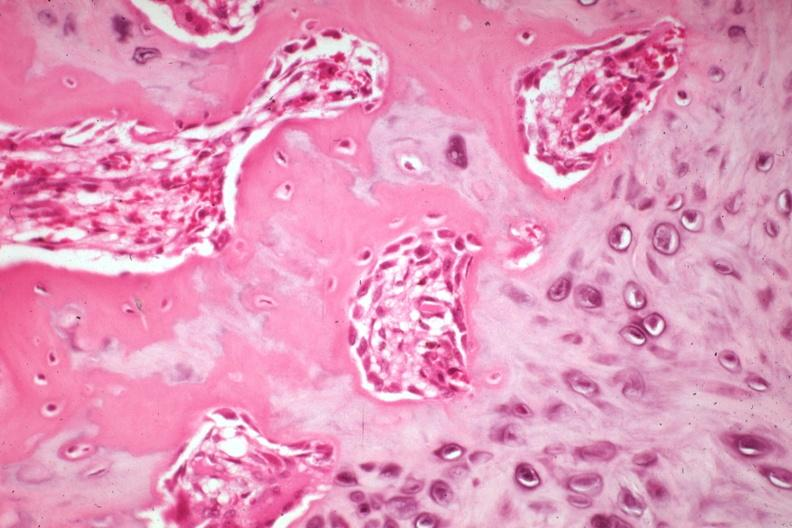what is a non-union?
Answer the question using a single word or phrase. Excellent example case 